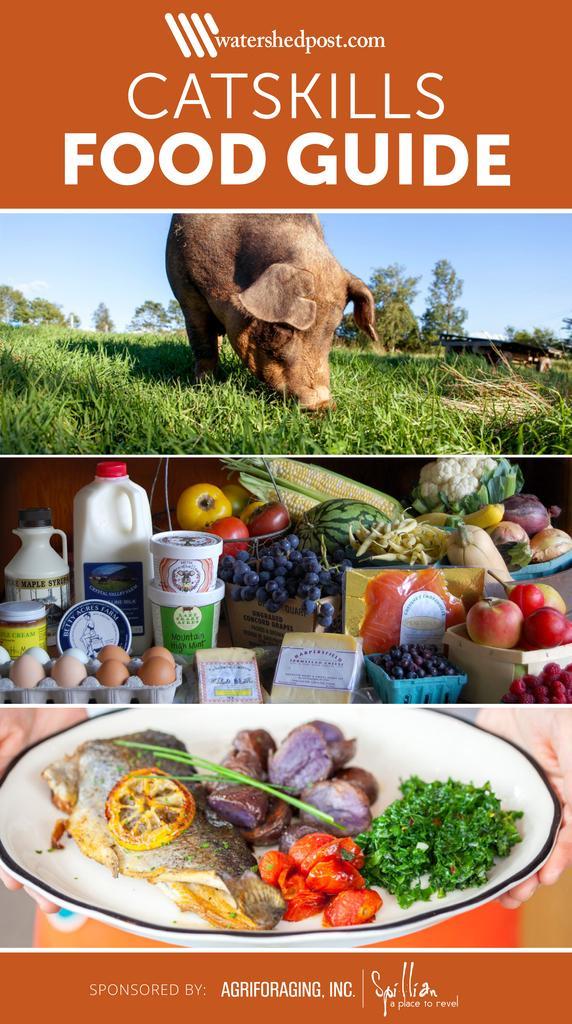Please provide a concise description of this image. In this image, we can see a poster. We can see some text. We can also see an animal and the ground is covered with grass. We can also see some food items. We can also see the hands of a person holding a container with some food items. 